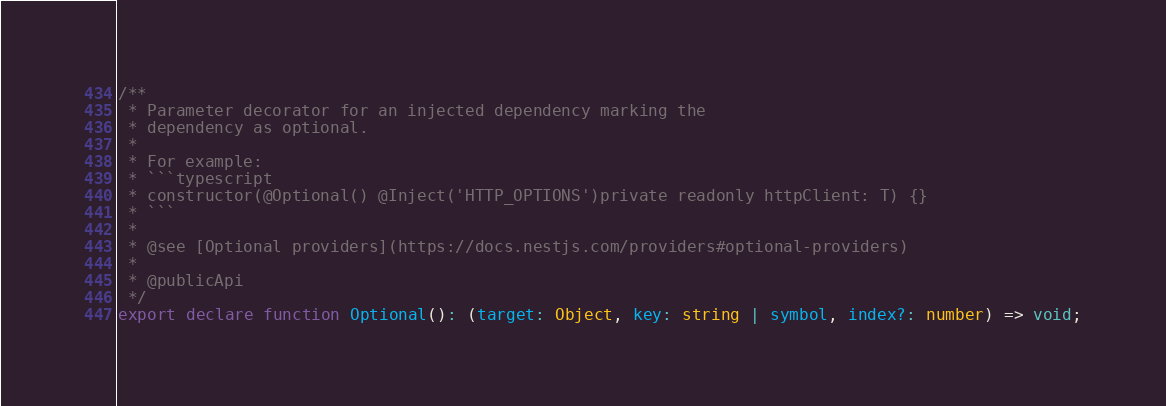Convert code to text. <code><loc_0><loc_0><loc_500><loc_500><_TypeScript_>/**
 * Parameter decorator for an injected dependency marking the
 * dependency as optional.
 *
 * For example:
 * ```typescript
 * constructor(@Optional() @Inject('HTTP_OPTIONS')private readonly httpClient: T) {}
 * ```
 *
 * @see [Optional providers](https://docs.nestjs.com/providers#optional-providers)
 *
 * @publicApi
 */
export declare function Optional(): (target: Object, key: string | symbol, index?: number) => void;
</code> 